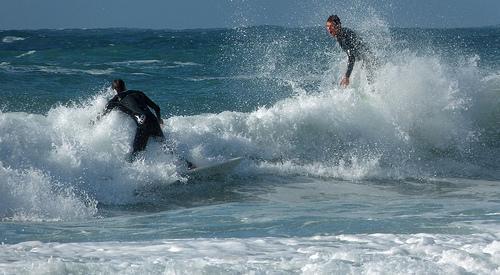How many people are there?
Give a very brief answer. 2. How many people are facing the camera?
Give a very brief answer. 1. 